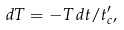Convert formula to latex. <formula><loc_0><loc_0><loc_500><loc_500>d T = - T \, d t / t _ { c } ^ { \prime } ,</formula> 